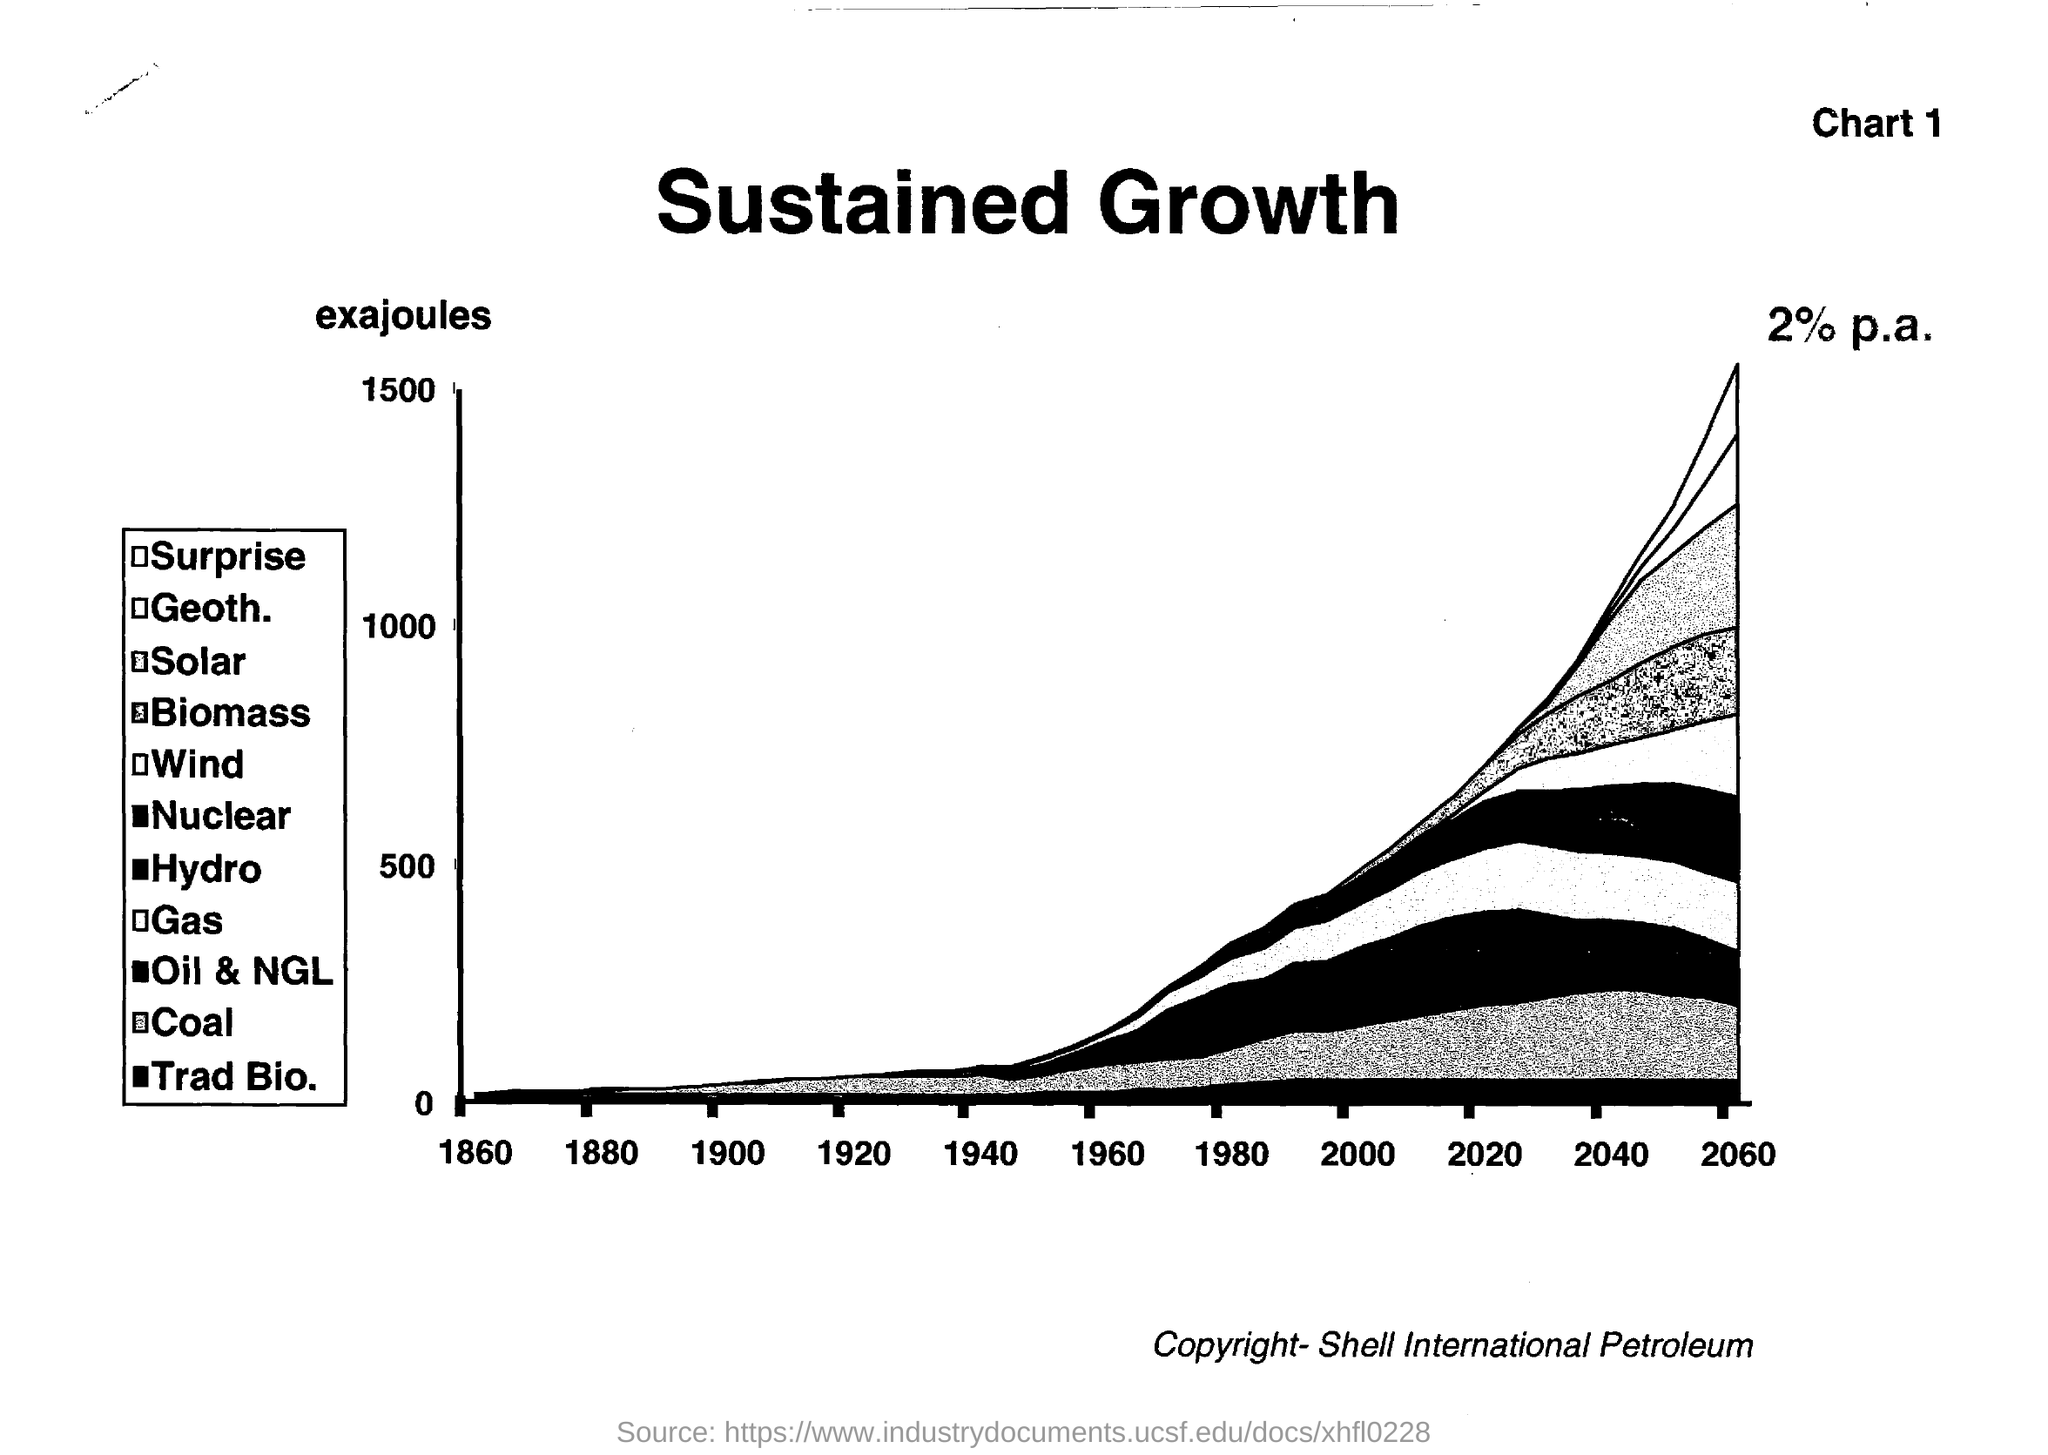What is the title of the document?
Ensure brevity in your answer.  Sustained Growth. 